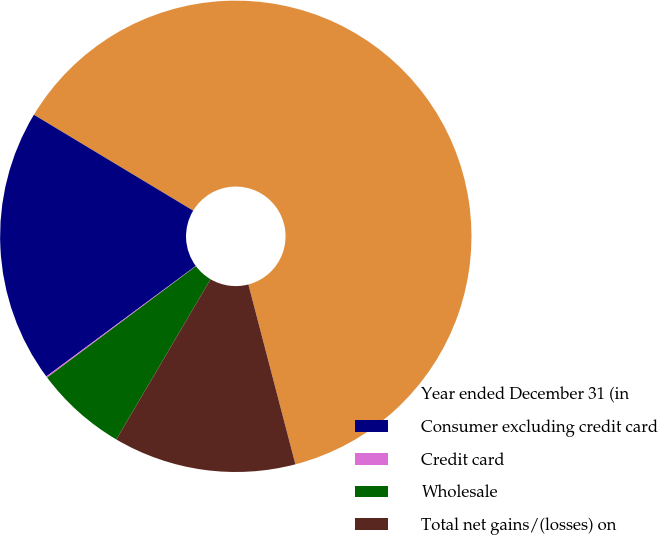Convert chart. <chart><loc_0><loc_0><loc_500><loc_500><pie_chart><fcel>Year ended December 31 (in<fcel>Consumer excluding credit card<fcel>Credit card<fcel>Wholesale<fcel>Total net gains/(losses) on<nl><fcel>62.3%<fcel>18.76%<fcel>0.09%<fcel>6.31%<fcel>12.53%<nl></chart> 